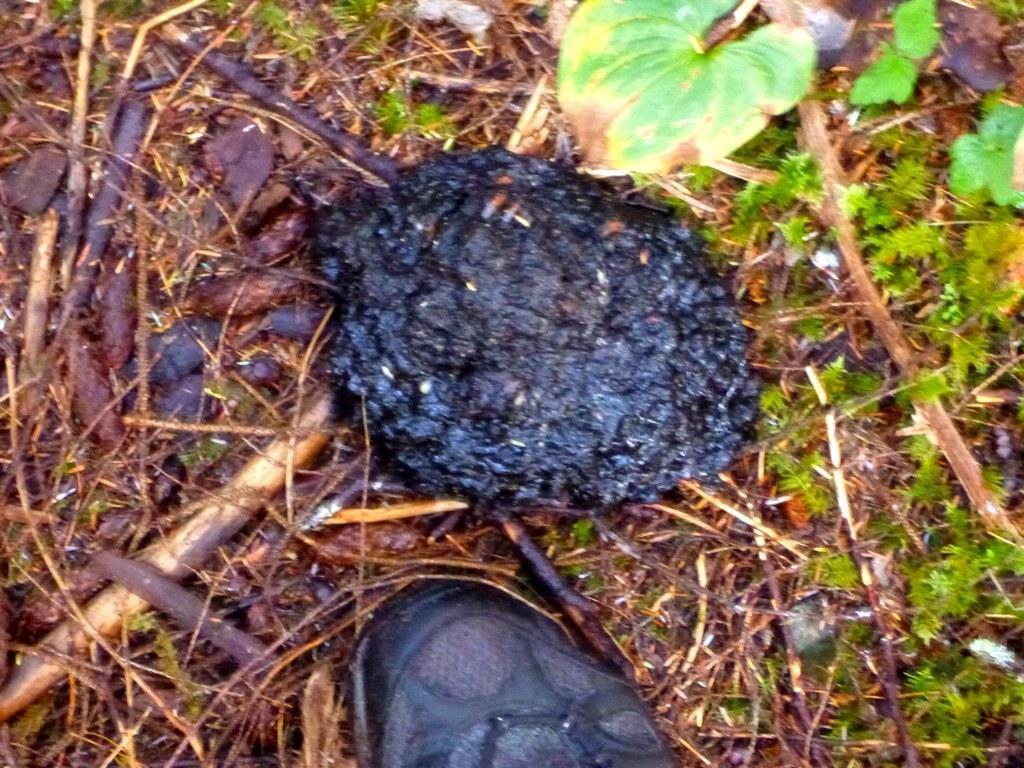Please provide a concise description of this image. In the image we can see grass, leaves and animal dung. There are even wooden pieces. 